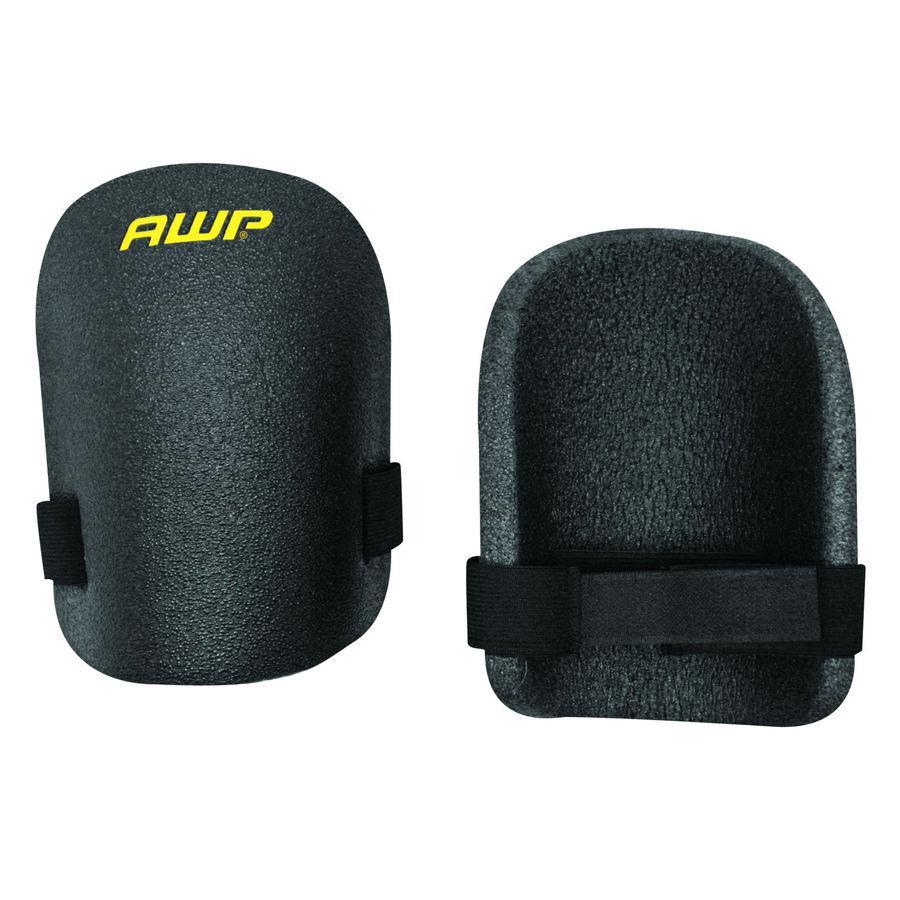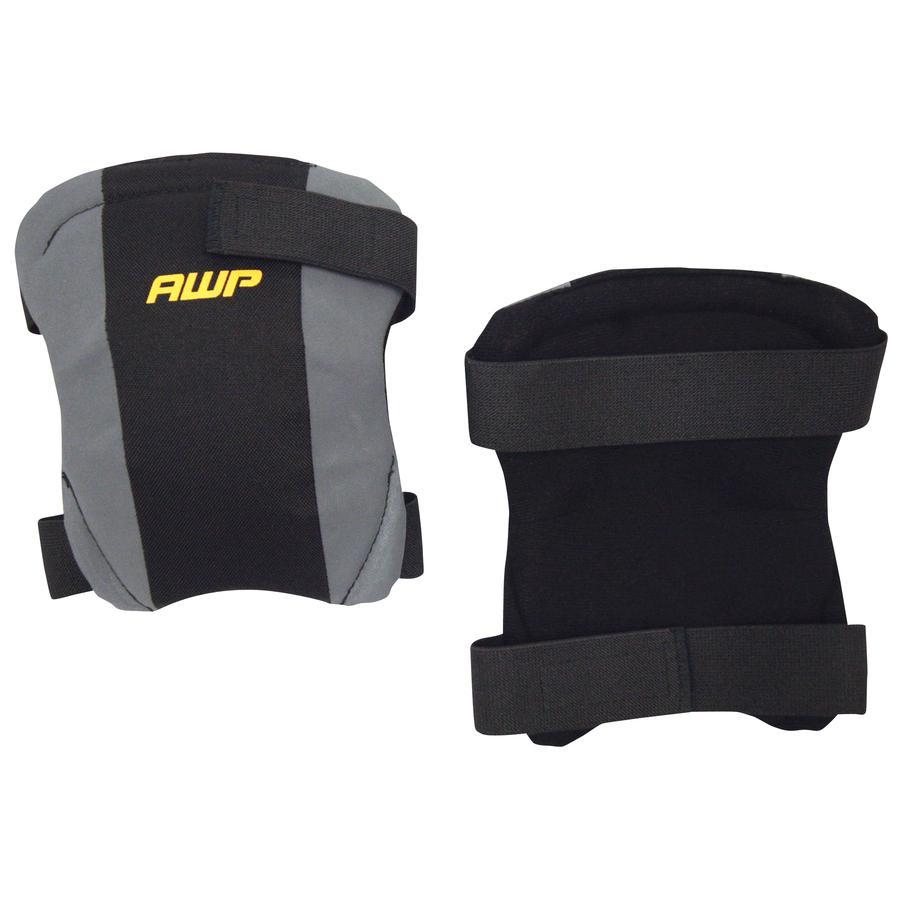The first image is the image on the left, the second image is the image on the right. Assess this claim about the two images: "There are two pairs of unworn knee pads". Correct or not? Answer yes or no. Yes. The first image is the image on the left, the second image is the image on the right. Given the left and right images, does the statement "Each image shows a pair of unworn knee pads." hold true? Answer yes or no. Yes. 